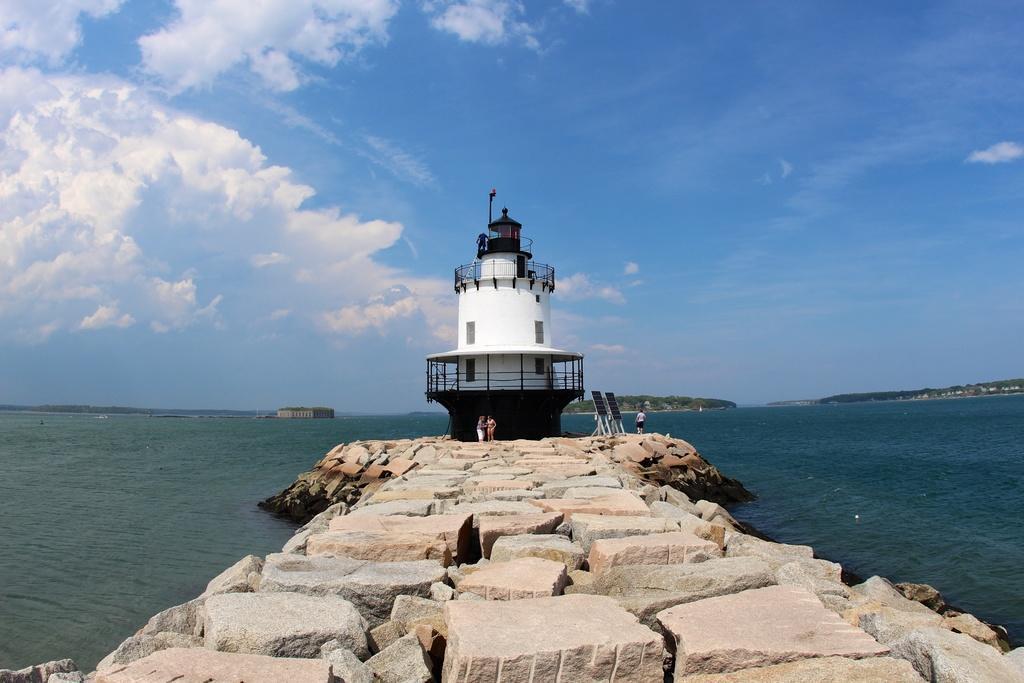Describe this image in one or two sentences. In this image, we can see a lighthouse with wall, railings and windows. At the bottom, we can see stones. Here few people are standing. Background we can see the sea and mountains. Top of the image, there is a cloudy sky. 